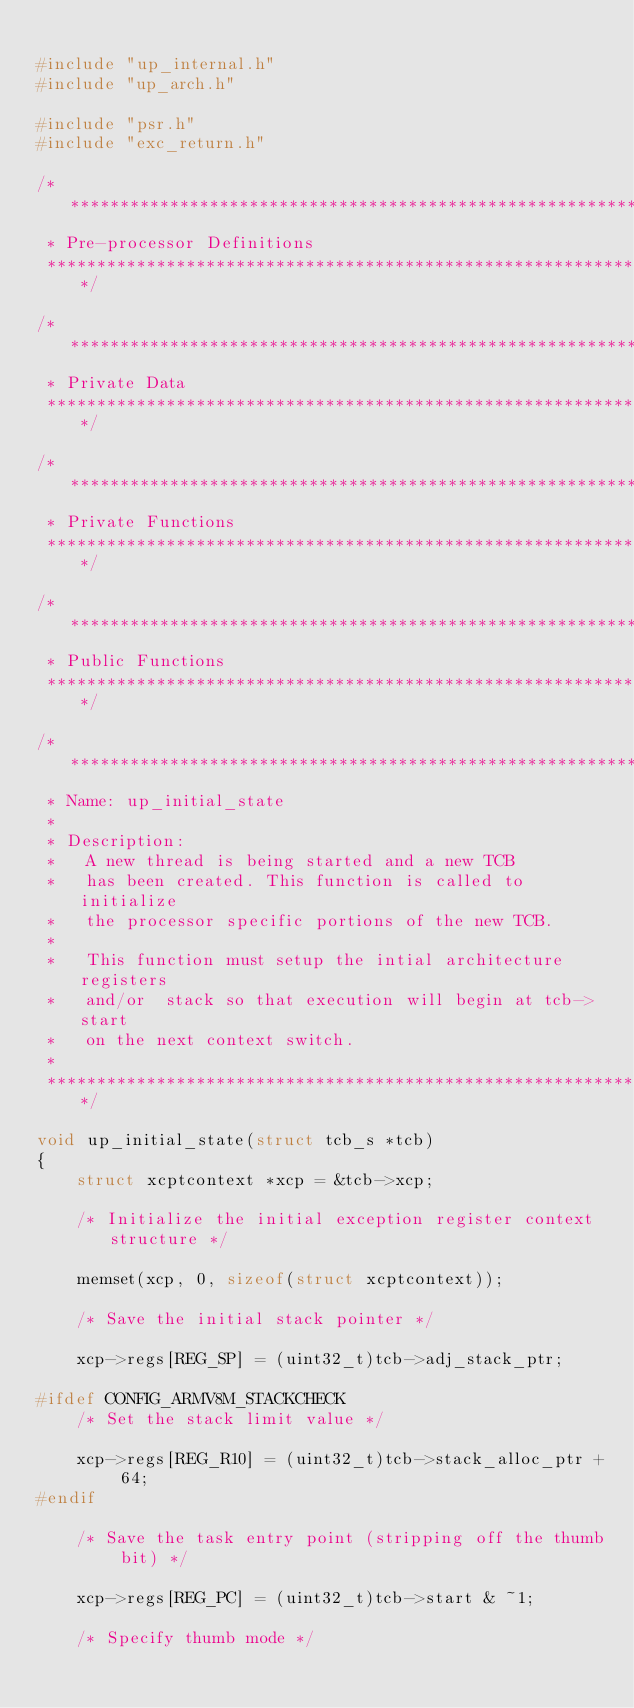Convert code to text. <code><loc_0><loc_0><loc_500><loc_500><_C_>
#include "up_internal.h"
#include "up_arch.h"

#include "psr.h"
#include "exc_return.h"

/****************************************************************************
 * Pre-processor Definitions
 ****************************************************************************/

/****************************************************************************
 * Private Data
 ****************************************************************************/

/****************************************************************************
 * Private Functions
 ****************************************************************************/

/****************************************************************************
 * Public Functions
 ****************************************************************************/

/****************************************************************************
 * Name: up_initial_state
 *
 * Description:
 *   A new thread is being started and a new TCB
 *   has been created. This function is called to initialize
 *   the processor specific portions of the new TCB.
 *
 *   This function must setup the intial architecture registers
 *   and/or  stack so that execution will begin at tcb->start
 *   on the next context switch.
 *
 ****************************************************************************/

void up_initial_state(struct tcb_s *tcb)
{
	struct xcptcontext *xcp = &tcb->xcp;

	/* Initialize the initial exception register context structure */

	memset(xcp, 0, sizeof(struct xcptcontext));

	/* Save the initial stack pointer */

	xcp->regs[REG_SP] = (uint32_t)tcb->adj_stack_ptr;

#ifdef CONFIG_ARMV8M_STACKCHECK
	/* Set the stack limit value */

	xcp->regs[REG_R10] = (uint32_t)tcb->stack_alloc_ptr + 64;
#endif

	/* Save the task entry point (stripping off the thumb bit) */

	xcp->regs[REG_PC] = (uint32_t)tcb->start & ~1;

	/* Specify thumb mode */
</code> 